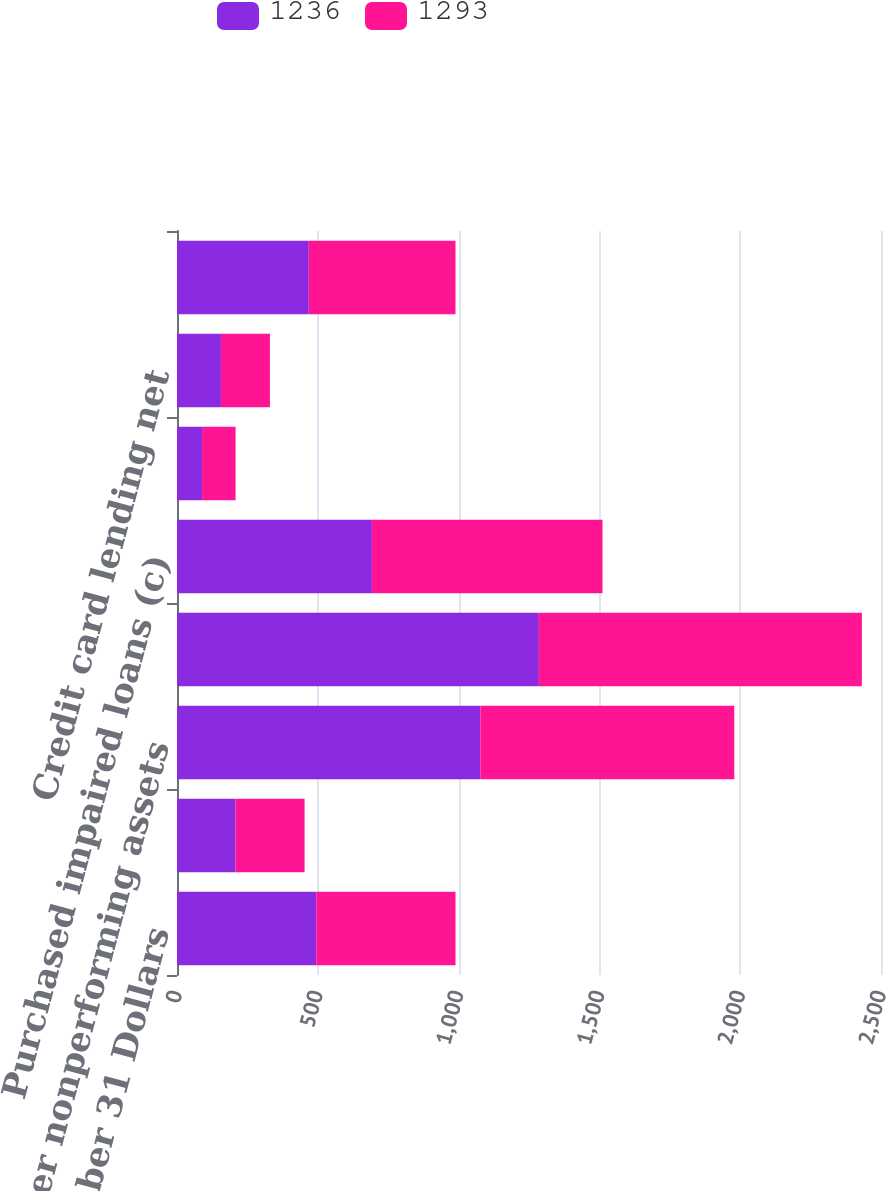<chart> <loc_0><loc_0><loc_500><loc_500><stacked_bar_chart><ecel><fcel>Year ended December 31 Dollars<fcel>Commercial nonperforming<fcel>Consumer nonperforming assets<fcel>Total nonperforming assets (b)<fcel>Purchased impaired loans (c)<fcel>Commercial lending net<fcel>Credit card lending net<fcel>Consumer lending (excluding<nl><fcel>1236<fcel>494.5<fcel>208<fcel>1077<fcel>1285<fcel>692<fcel>89<fcel>156<fcel>468<nl><fcel>1293<fcel>494.5<fcel>245<fcel>902<fcel>1147<fcel>819<fcel>119<fcel>174<fcel>521<nl></chart> 